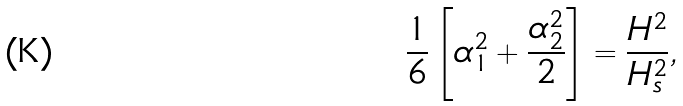Convert formula to latex. <formula><loc_0><loc_0><loc_500><loc_500>\frac { 1 } { 6 } \left [ \alpha _ { 1 } ^ { 2 } + \frac { \alpha _ { 2 } ^ { 2 } } 2 \right ] = \frac { H ^ { 2 } } { H _ { s } ^ { 2 } } ,</formula> 